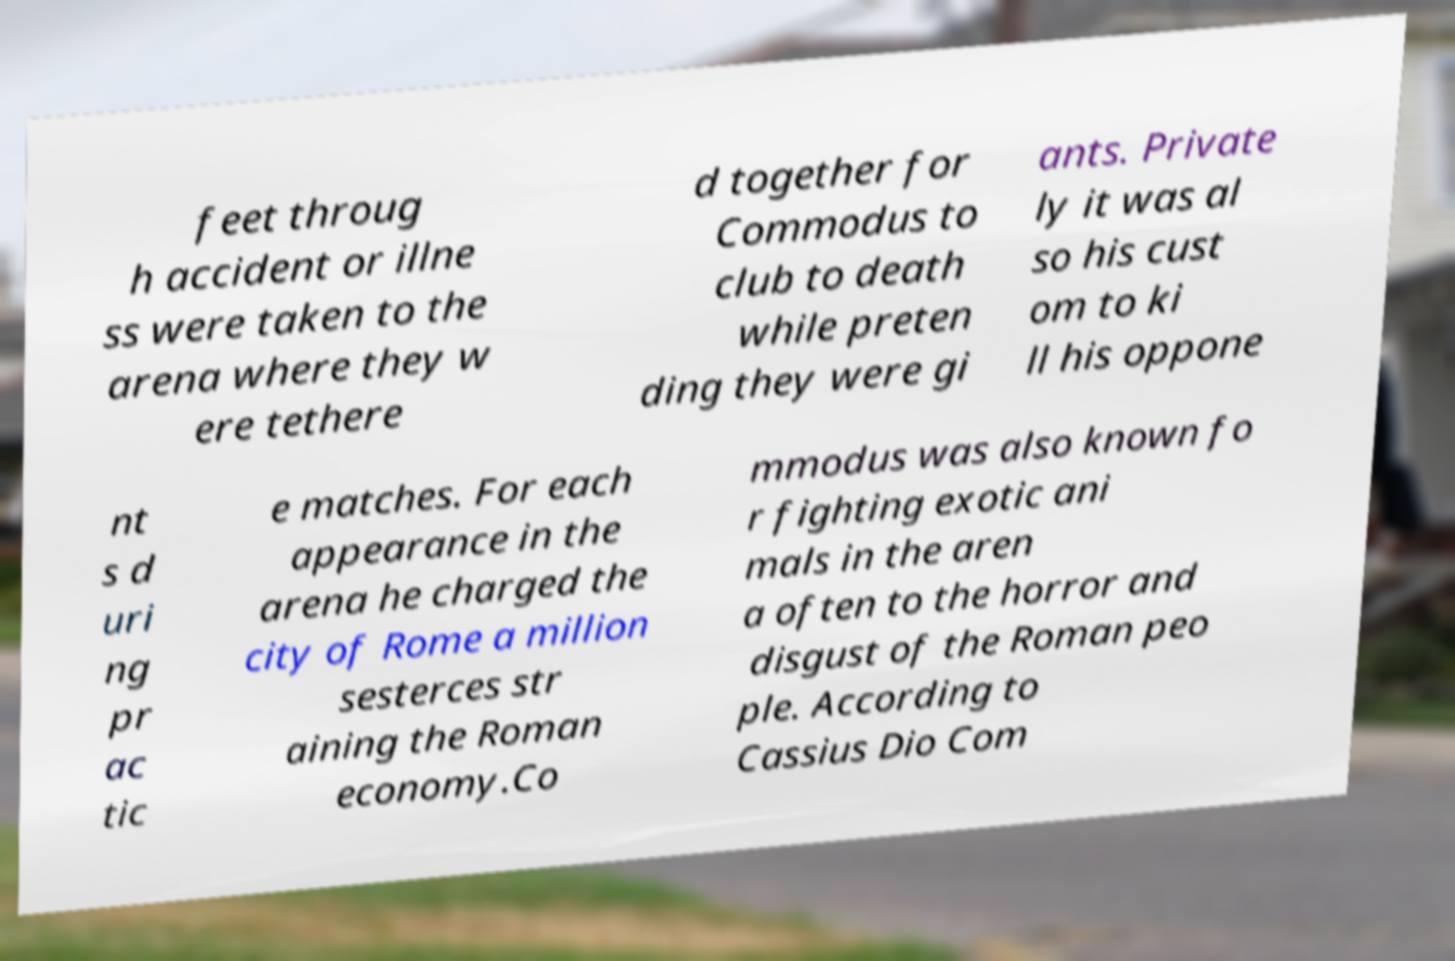There's text embedded in this image that I need extracted. Can you transcribe it verbatim? feet throug h accident or illne ss were taken to the arena where they w ere tethere d together for Commodus to club to death while preten ding they were gi ants. Private ly it was al so his cust om to ki ll his oppone nt s d uri ng pr ac tic e matches. For each appearance in the arena he charged the city of Rome a million sesterces str aining the Roman economy.Co mmodus was also known fo r fighting exotic ani mals in the aren a often to the horror and disgust of the Roman peo ple. According to Cassius Dio Com 